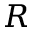Convert formula to latex. <formula><loc_0><loc_0><loc_500><loc_500>R</formula> 